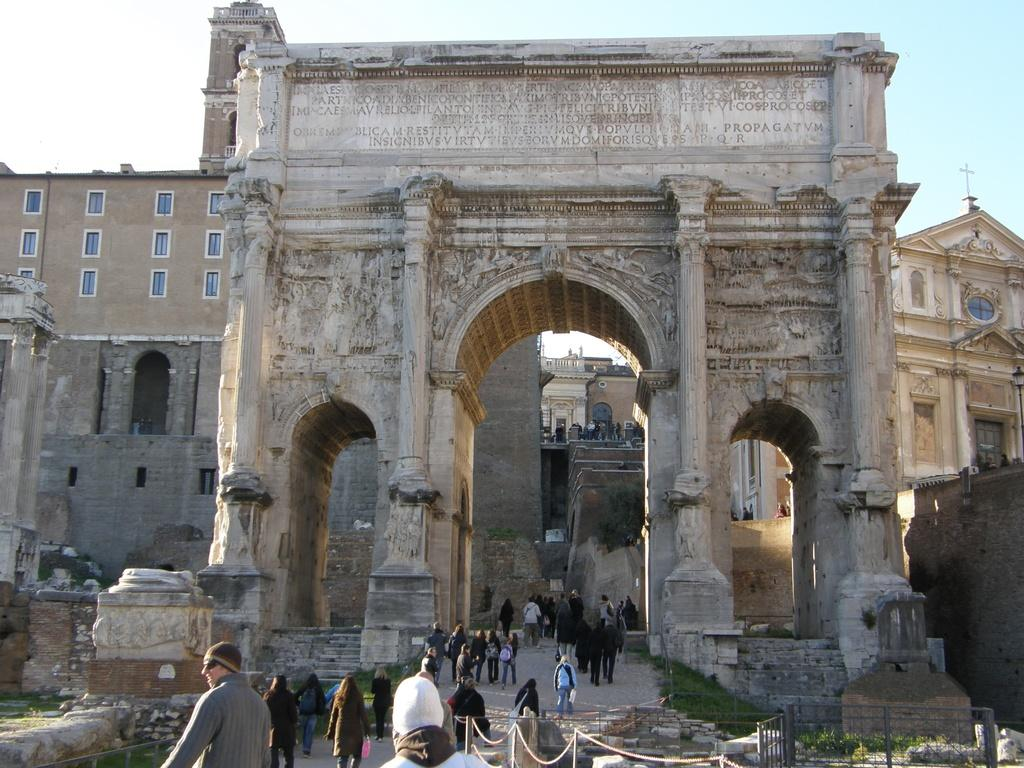What are the people in the image doing? The people in the image are walking. Where are the people walking? They are walking through a historical building. What else can be seen in the background of the image? There are other buildings visible in the background. What is visible in the sky in the image? The sky is visible in the image. What type of statement is being made by the smoke in the image? There is no smoke present in the image, so no statement can be made by it. How is the thread being used by the people in the image? There is no thread present in the image, so it cannot be used by the people. 